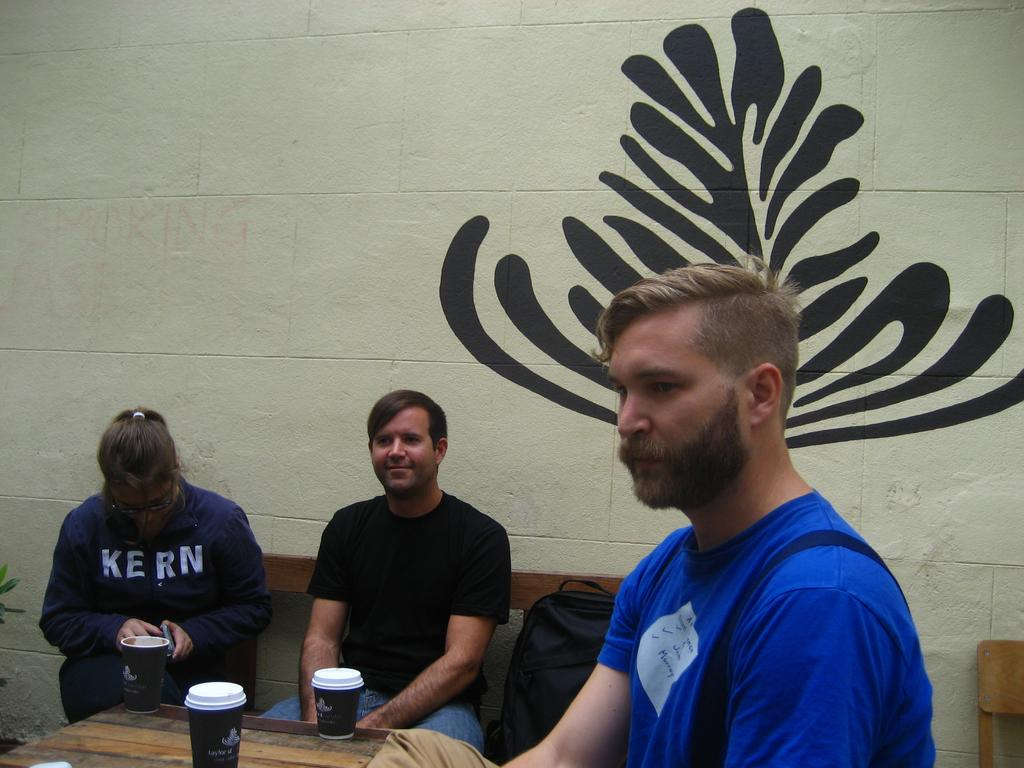What are the people in the image doing? The people in the image are sitting on benches. What is located on the table in the image? There are glasses on the table. What can be seen in the background of the image? There is a wall in the background of the image. What is on the wall in the image? There is a painting on the wall. How many cows are visible in the image? There are no cows present in the image. What force is being applied to the painting on the wall? There is no force being applied to the painting in the image; it is simply hanging on the wall. 